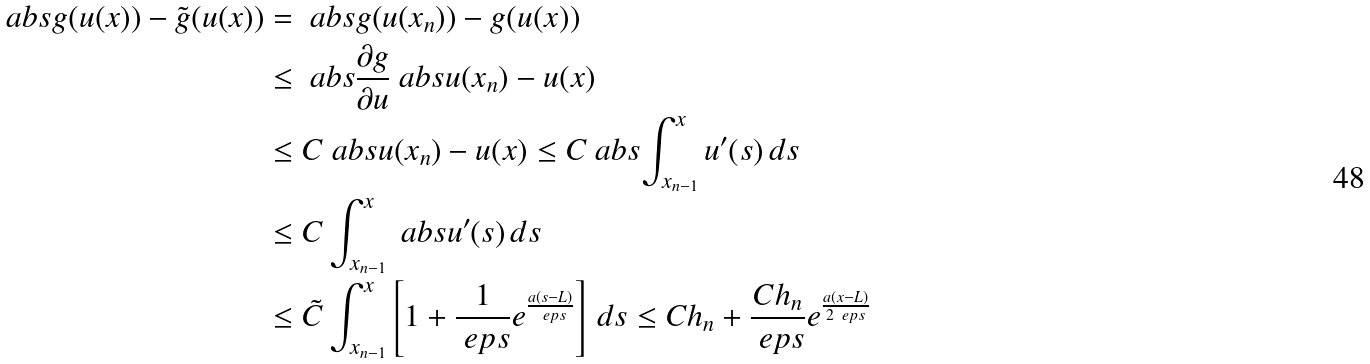Convert formula to latex. <formula><loc_0><loc_0><loc_500><loc_500>\ a b s { g ( u ( x ) ) - \tilde { g } ( u ( x ) ) } & = \ a b s { g ( u ( x _ { n } ) ) - g ( u ( x ) ) } \\ & \leq \ a b s { \frac { \partial g } { \partial u } } \ a b s { u ( x _ { n } ) - u ( x ) } \\ & \leq C \ a b s { u ( x _ { n } ) - u ( x ) } \leq C \ a b s { \int _ { x _ { n - 1 } } ^ { x } u ^ { \prime } ( s ) \, d s } \\ & \leq C \int _ { x _ { n - 1 } } ^ { x } \ a b s { u ^ { \prime } ( s ) } \, d s \\ & \leq \tilde { C } \int _ { x _ { n - 1 } } ^ { x } \left [ 1 + \frac { 1 } { \ e p s } e ^ { \frac { a ( s - L ) } { \ e p s } } \right ] \, d s \leq C h _ { n } + \frac { C h _ { n } } { \ e p s } e ^ { \frac { a ( x - L ) } { 2 \ e p s } }</formula> 